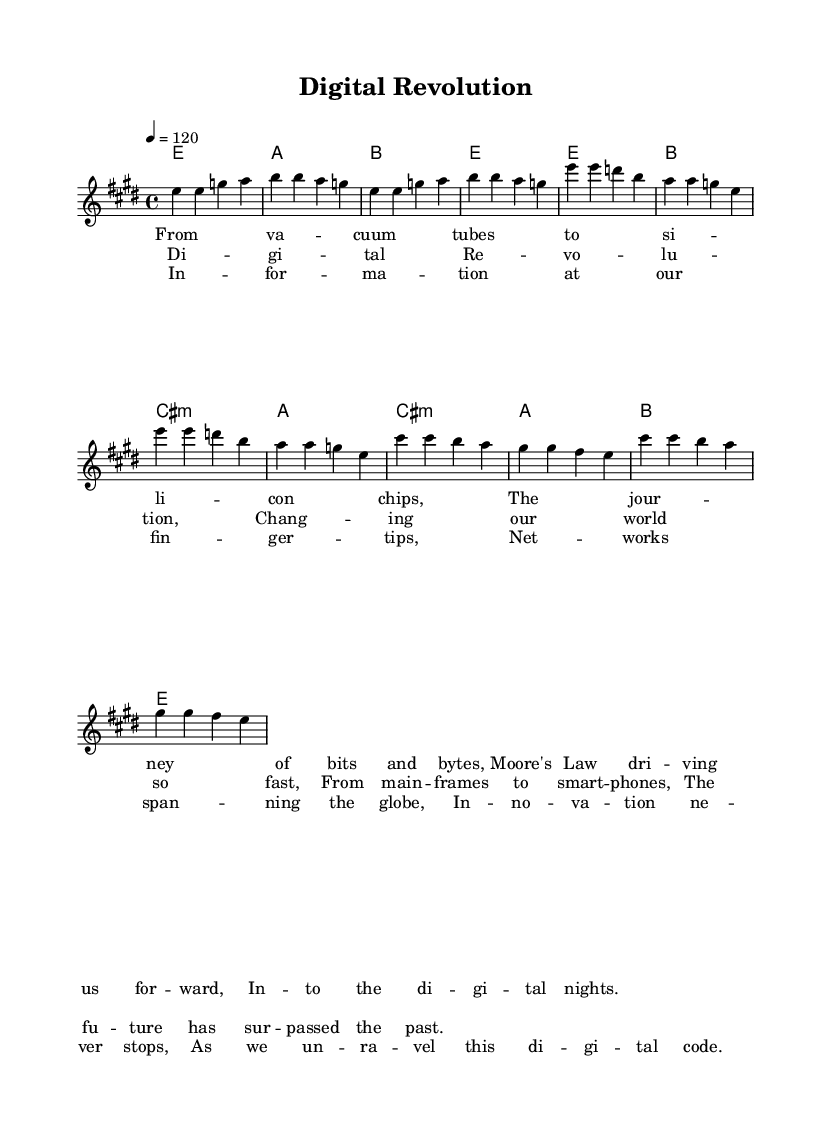What is the time signature of this music? The time signature is indicated at the beginning of the sheet music as 4/4, meaning there are four beats in each measure and a quarter note receives one beat.
Answer: 4/4 What is the key signature of this music? The key signature is e major, which has four sharps (F#, C#, G#, and D#). This can be determined from the key indication at the start of the piece.
Answer: E major What is the tempo marking of this piece? The tempo is indicated in the global settings as "4 = 120," which means there are 120 beats per minute with a quarter note getting one beat.
Answer: 120 How many measures are in the verse section? Counting the measures in the verse section, there are four measures shown, indicated by the four sets of notes in the melody line that pertain to the verse.
Answer: 4 What type of musical form is used in this piece? This piece follows a verse-chorus structure which is common in rock music, identified by the repetition of sections labeled as verses and choruses.
Answer: Verse-chorus What does the bridge in the music introduce regarding themes? The bridge lyrics introduce themes of connectivity and innovation in technology, serving as a transition that contrasts with the verse and chorus content.
Answer: Connectivity What instrument is primarily indicated to perform this piece? The staff notations present indicate that the music is for a melodic instrument, particularly suited for a piano or a similar melodic instrument, as denoted by the absence of traditional guitar tablature notation.
Answer: Piano 